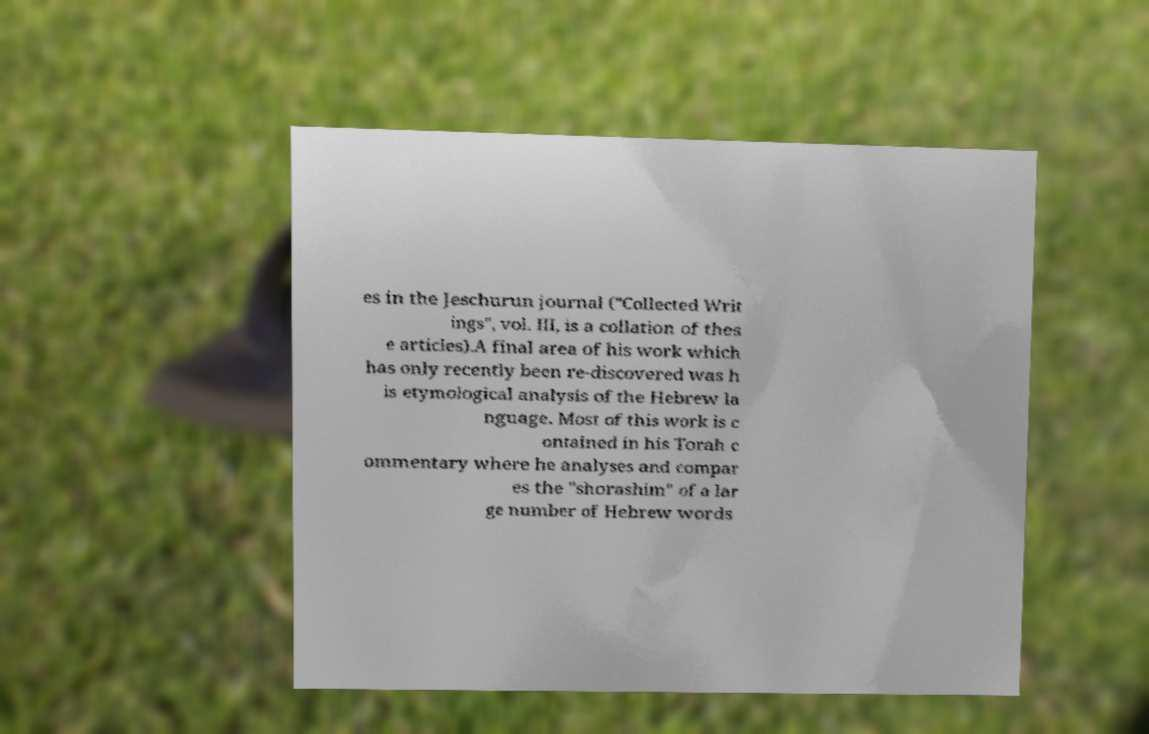Please read and relay the text visible in this image. What does it say? es in the Jeschurun journal ("Collected Writ ings", vol. III, is a collation of thes e articles).A final area of his work which has only recently been re-discovered was h is etymological analysis of the Hebrew la nguage. Most of this work is c ontained in his Torah c ommentary where he analyses and compar es the "shorashim" of a lar ge number of Hebrew words 